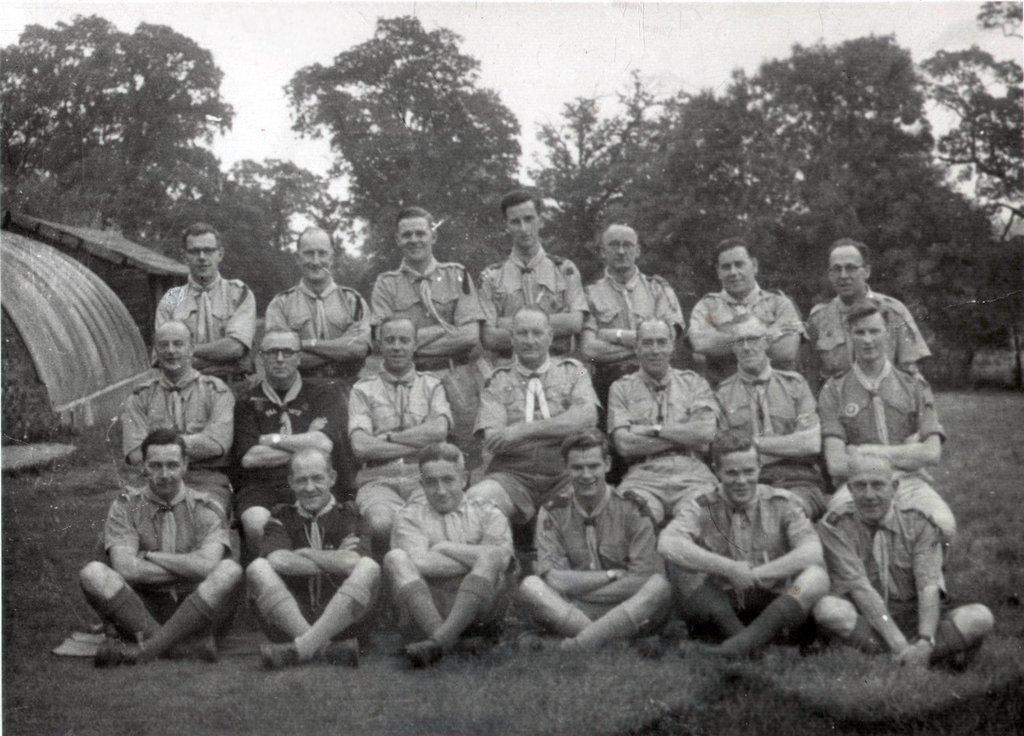Describe this image in one or two sentences. This is a black and white picture. Here we can see group of people posing to a camera. This is ground. In the background we can see trees and sky. 